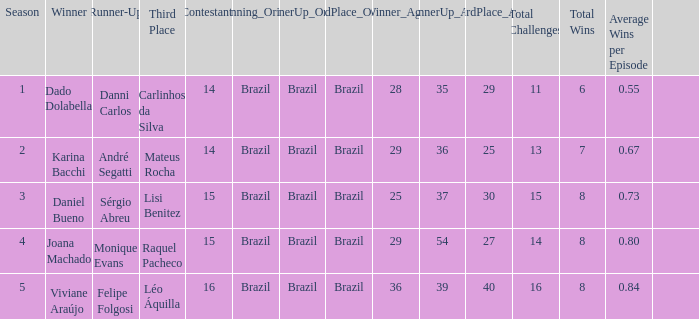How many contestants were there when the runner-up was Monique Evans? 15.0. 